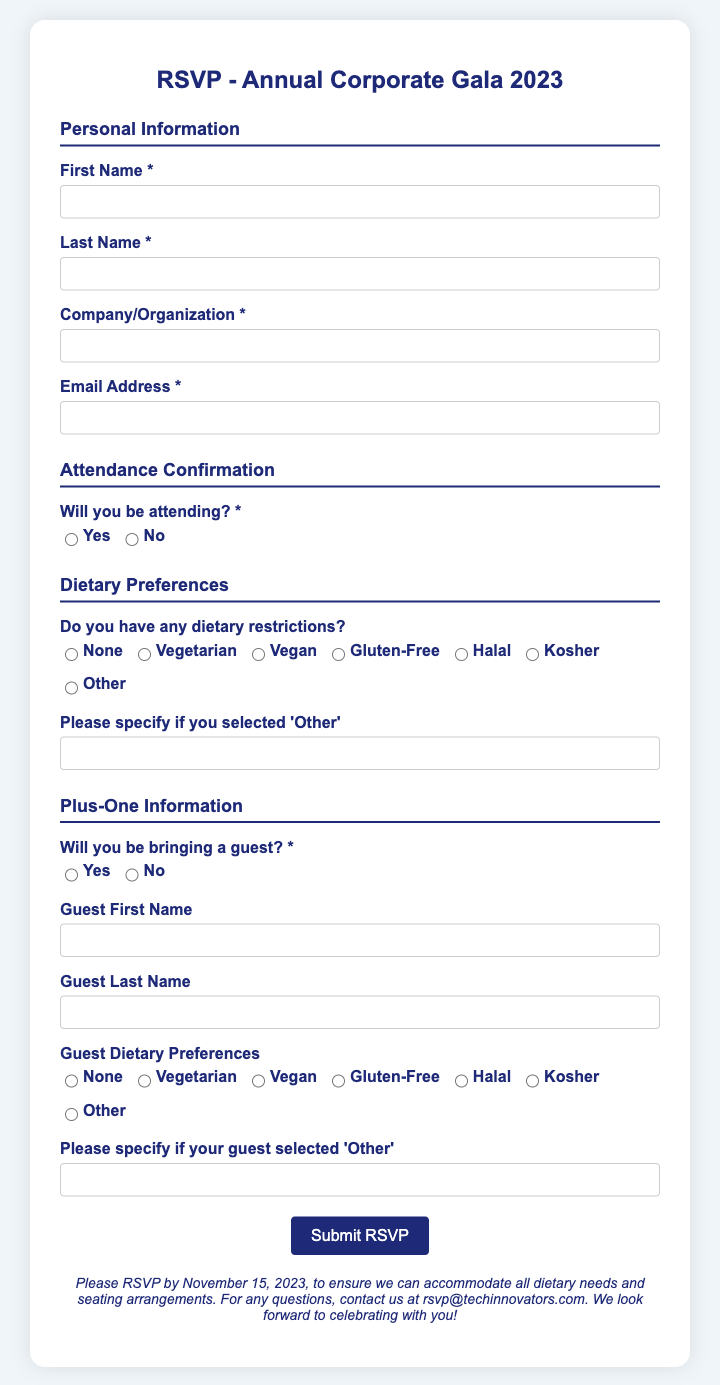What is the event title? The event title is indicated at the beginning of the RSVP card, presented as "RSVP - Annual Corporate Gala 2023".
Answer: Annual Corporate Gala 2023 What is the RSVP submission deadline? The deadline for RSVP submissions is mentioned in the note at the bottom of the form.
Answer: November 15, 2023 What information is required in the personal section? The personal section requires the individual's first name, last name, company/organization, and email address.
Answer: First Name, Last Name, Company/Organization, Email Address What dietary preference option is not listed? The options for dietary preferences include various common restrictions, but not all possible preferences are mentioned. For example, "Pescatarian" is not listed.
Answer: Pescatarian How many dietary preference options are available? The dietary preferences section provides six options, including 'Other' for custom inputs.
Answer: Seven Will you be bringing a guest? The RSVP card has a question specifically asking if the responder will bring a guest.
Answer: Yes/No What does the submit button say? The submit button at the bottom of the form indicates the action to take once the form is filled out.
Answer: Submit RSVP What type of information is needed for the guest? The RSVP asks for the first name, last name, and dietary preferences of the guest if the participant selects to bring one.
Answer: Guest First Name, Guest Last Name, Guest Dietary Preferences What is the email for inquiries? The RSVP card includes a note with contact information for questions, specifically an email address.
Answer: rsvp@techinnovators.com 